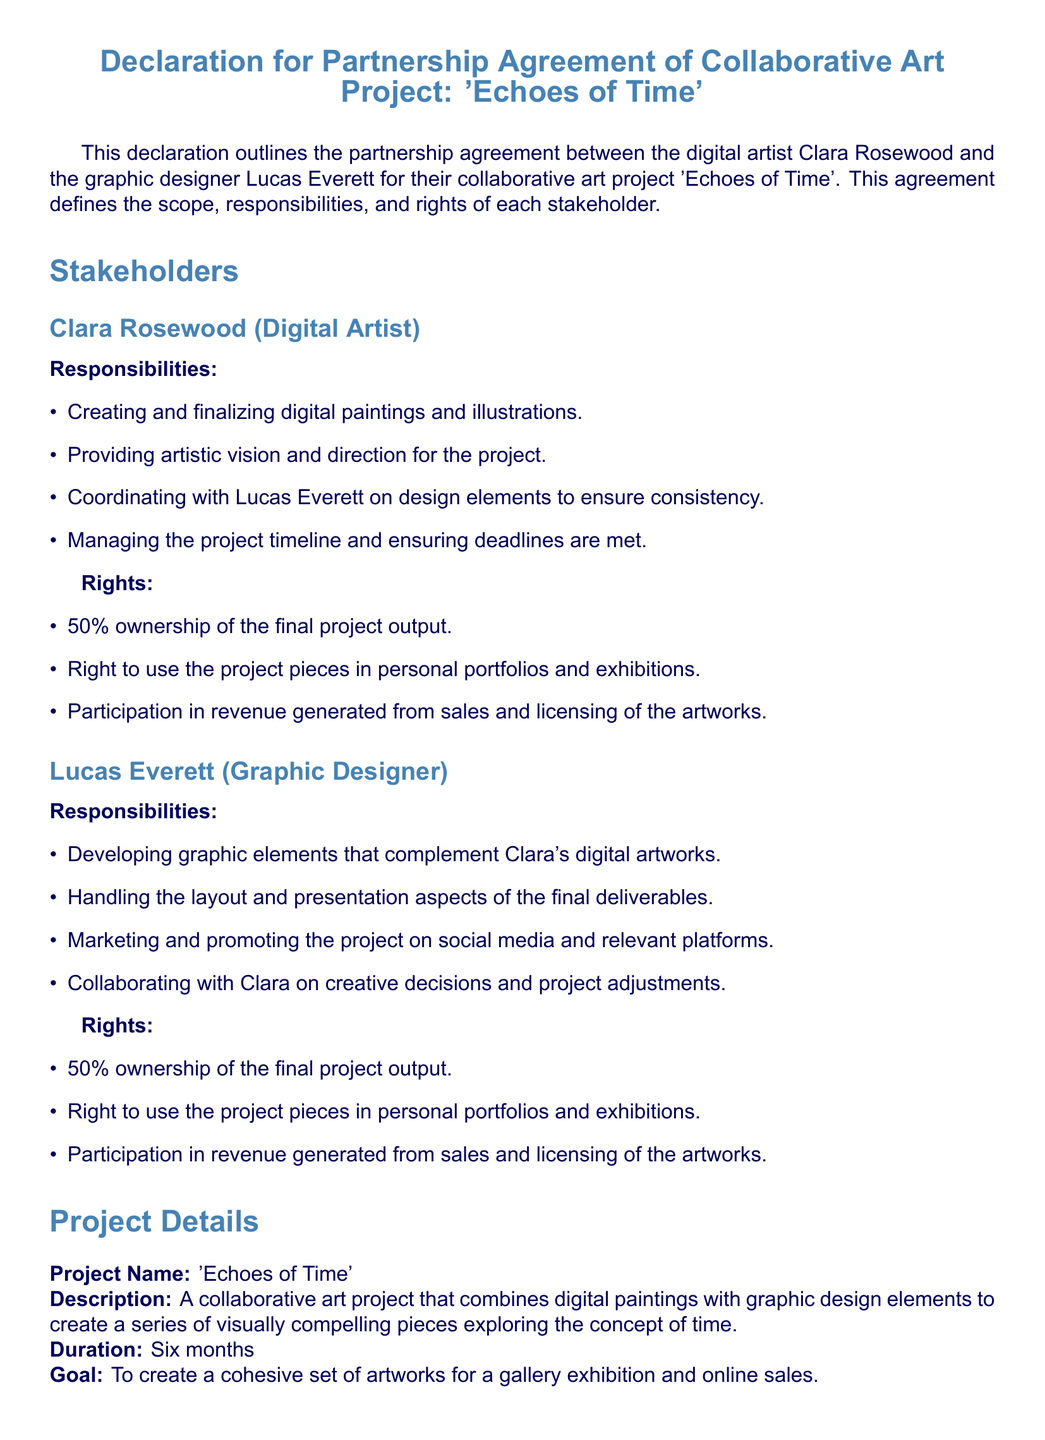What is the title of the project? The title of the project is stated in the document as 'Echoes of Time'.
Answer: 'Echoes of Time' Who are the stakeholders involved? The document lists the two stakeholders involved in the project, Clara Rosewood and Lucas Everett.
Answer: Clara Rosewood and Lucas Everett How long is the project duration? The duration of the project is explicitly stated in the document as six months.
Answer: Six months What percentage of ownership does Clara Rosewood have? The document states that Clara Rosewood has 50% ownership of the final project output.
Answer: 50% What are the financial terms for cost sharing? The document specifies that both parties agree to share any project-related costs equally.
Answer: Equally What is the goal of the collaborative art project? The document outlines the goal as creating a cohesive set of artworks for a gallery exhibition and online sales.
Answer: Gallery exhibition and online sales What happens if one party fails to fulfill their responsibilities? The document states that the partnership can be terminated if one party fails to fulfill their responsibilities.
Answer: Termination of the partnership How are revenues generated from the project split? The document details that all revenues generated will be split equally (50/50) between the two stakeholders.
Answer: 50/50 Which rights does Lucas Everett hold regarding the project? The document indicates that Lucas Everett has the right to use the project pieces in personal portfolios and exhibitions.
Answer: Use in personal portfolios and exhibitions 